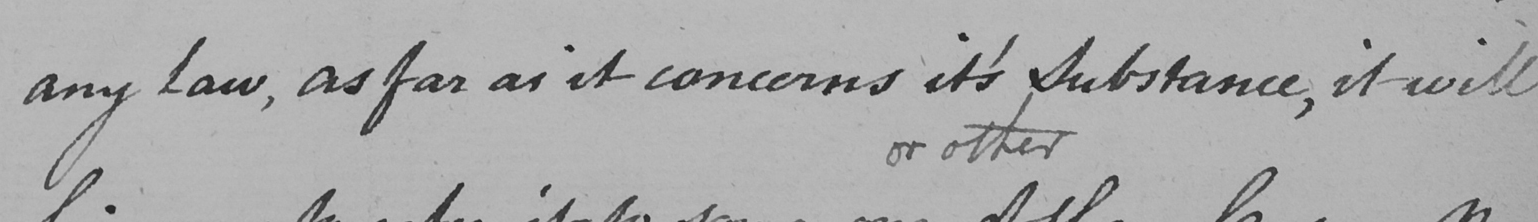What text is written in this handwritten line? any Law , as far as it concerns it ' s Substance , it will 